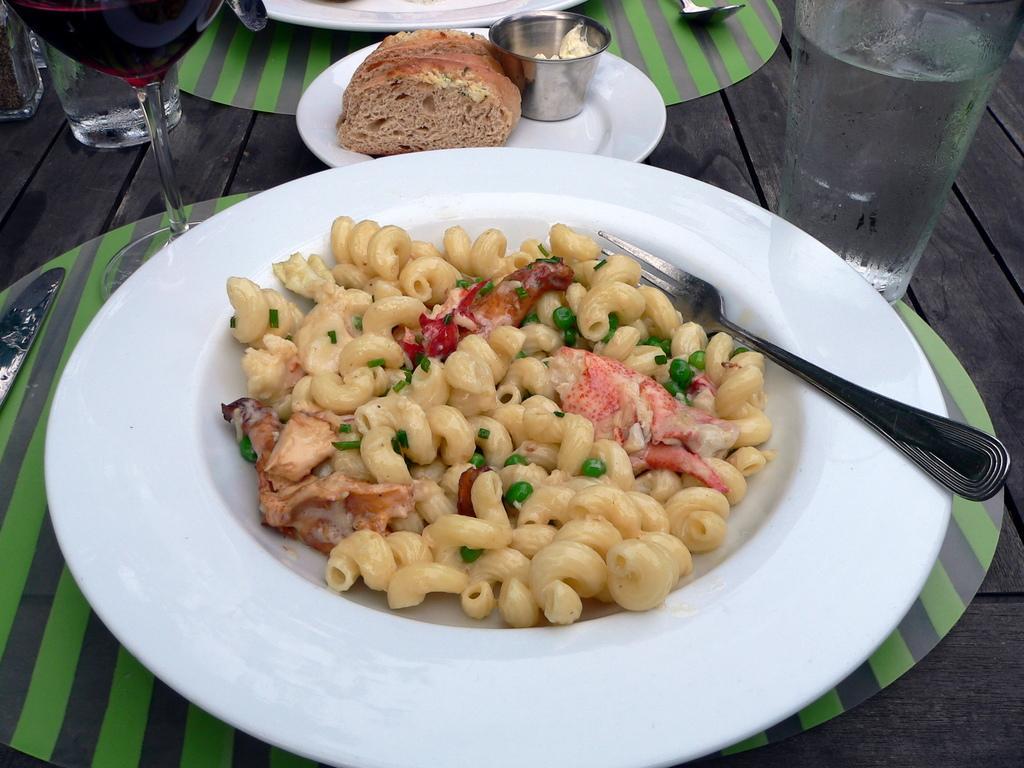Please provide a concise description of this image. In this image I can see food items in the plates. I can see a glass of water. 